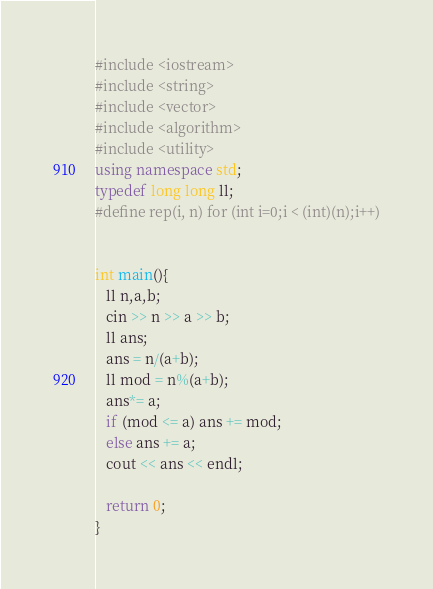Convert code to text. <code><loc_0><loc_0><loc_500><loc_500><_C++_>#include <iostream>
#include <string>
#include <vector>
#include <algorithm>
#include <utility>
using namespace std;
typedef long long ll;
#define rep(i, n) for (int i=0;i < (int)(n);i++)


int main(){
   ll n,a,b;
   cin >> n >> a >> b;
   ll ans;
   ans = n/(a+b);
   ll mod = n%(a+b);
   ans*= a;
   if (mod <= a) ans += mod;
   else ans += a;
   cout << ans << endl;

   return 0;
}

</code> 